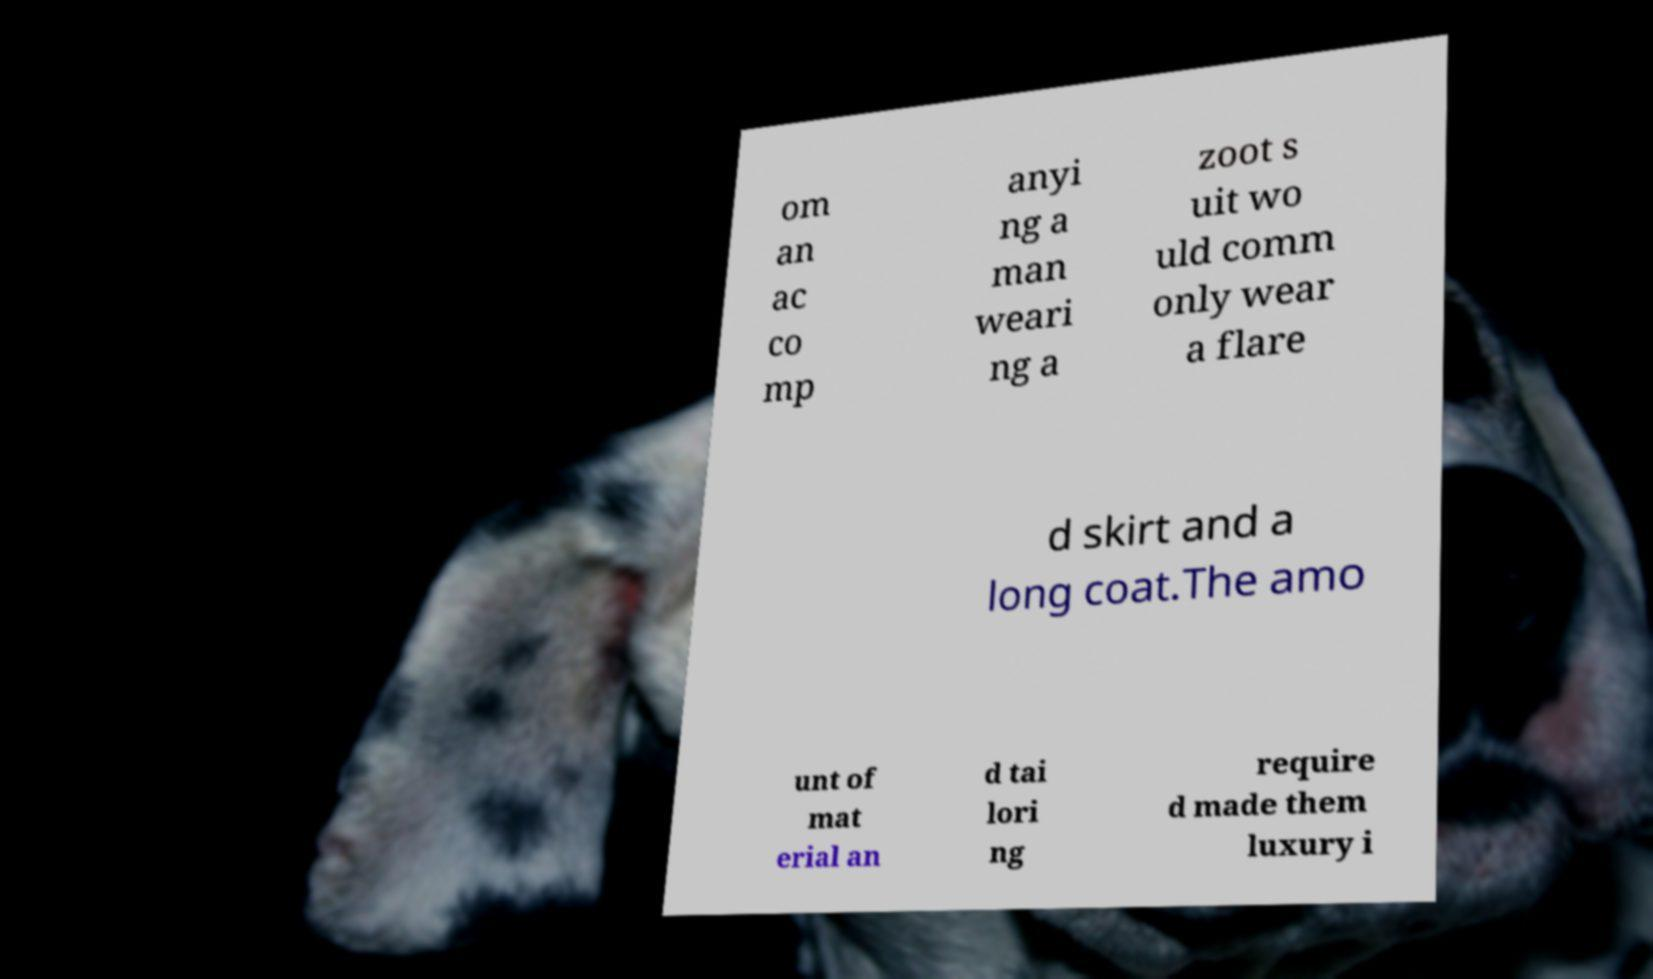What messages or text are displayed in this image? I need them in a readable, typed format. om an ac co mp anyi ng a man weari ng a zoot s uit wo uld comm only wear a flare d skirt and a long coat.The amo unt of mat erial an d tai lori ng require d made them luxury i 